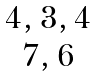Convert formula to latex. <formula><loc_0><loc_0><loc_500><loc_500>\begin{matrix} { 4 , 3 , 4 } \\ { 7 , 6 } \end{matrix}</formula> 